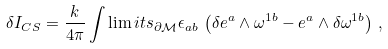<formula> <loc_0><loc_0><loc_500><loc_500>\delta I _ { C S } = \frac { k } { 4 \pi } \int \lim i t s _ { \partial \mathcal { M } } \epsilon _ { a b } \, \left ( \delta e ^ { a } \wedge \omega ^ { 1 b } - e ^ { a } \wedge \delta \omega ^ { 1 b } \right ) \, ,</formula> 